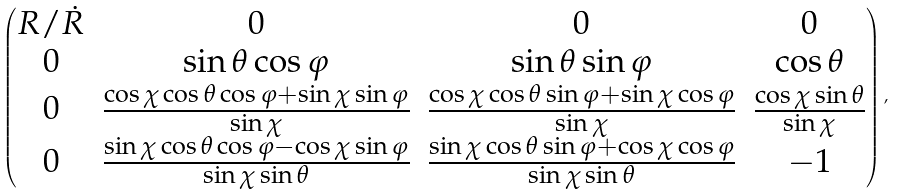Convert formula to latex. <formula><loc_0><loc_0><loc_500><loc_500>\begin{pmatrix} R / \dot { R } & 0 & 0 & 0 \\ 0 & \sin { \theta } \cos { \varphi } & \sin { \theta } \sin { \varphi } & \cos { \theta } \\ 0 & \frac { \cos { \chi } \cos { \theta } \cos { \varphi } + \sin { \chi } \sin { \varphi } } { \sin { \chi } } & \frac { \cos { \chi } \cos { \theta } \sin { \varphi } + \sin { \chi } \cos { \varphi } } { \sin { \chi } } & \frac { \cos { \chi } \sin { \theta } } { \sin { \chi } } \\ 0 & \frac { \sin { \chi } \cos { \theta } \cos { \varphi } - \cos { \chi } \sin { \varphi } } { \sin { \chi } \sin { \theta } } & \frac { \sin { \chi } \cos { \theta } \sin { \varphi } + \cos { \chi } \cos { \varphi } } { \sin { \chi } \sin { \theta } } & - 1 \end{pmatrix} ,</formula> 